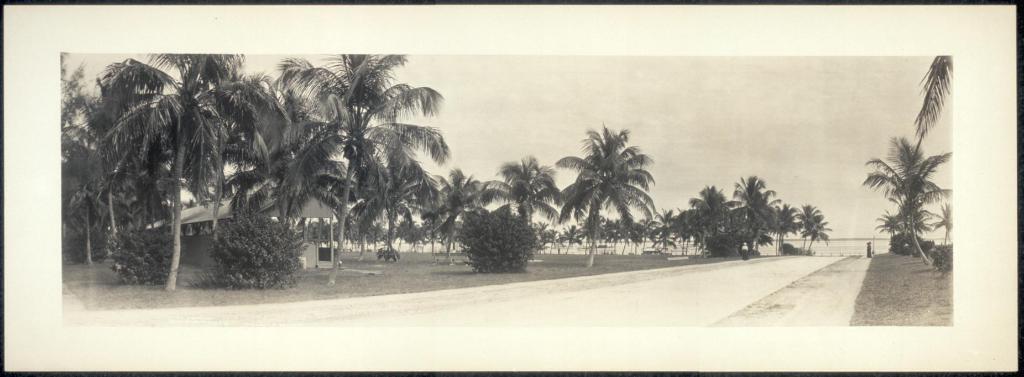Describe this image in one or two sentences. This image contains a picture frame. There are trees and plants on the grassland. Bottom of the image there is a road. Behind there is a lake. Left side there is a house. Top of the image there is sky 